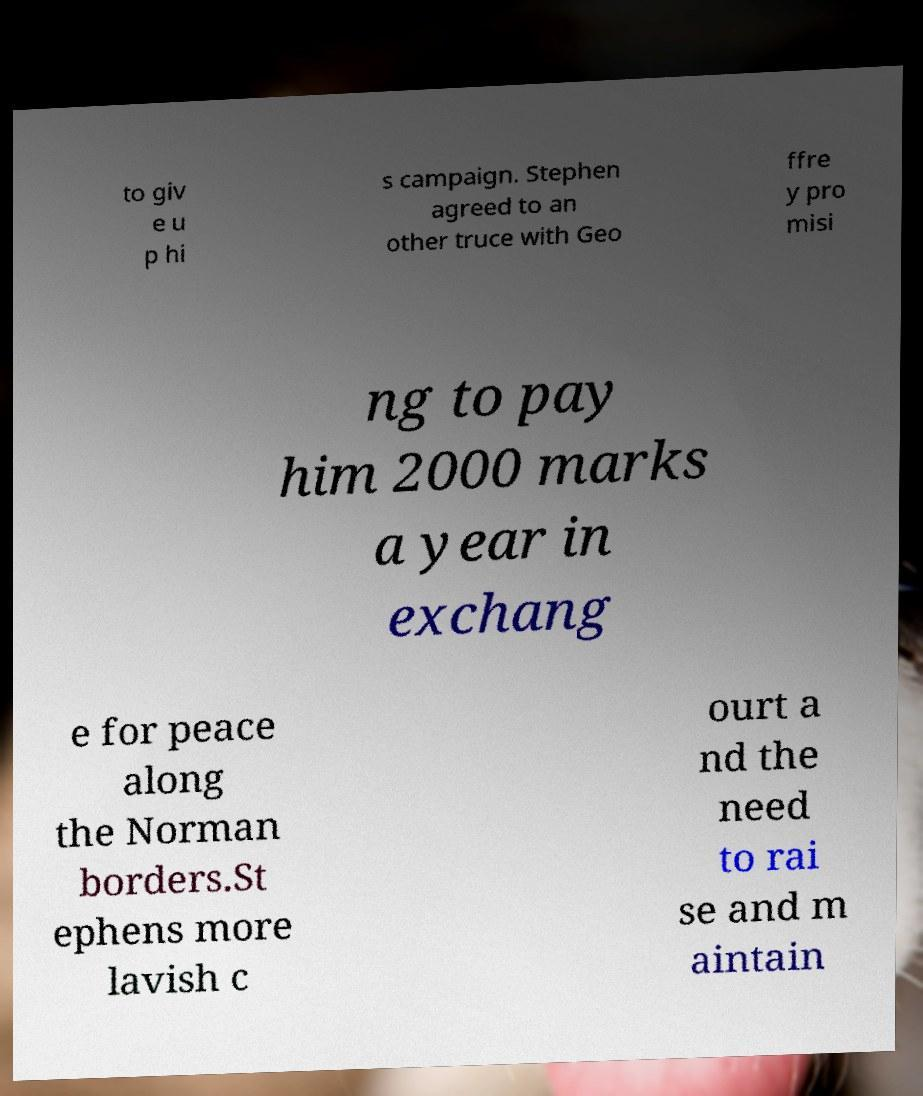Please read and relay the text visible in this image. What does it say? to giv e u p hi s campaign. Stephen agreed to an other truce with Geo ffre y pro misi ng to pay him 2000 marks a year in exchang e for peace along the Norman borders.St ephens more lavish c ourt a nd the need to rai se and m aintain 